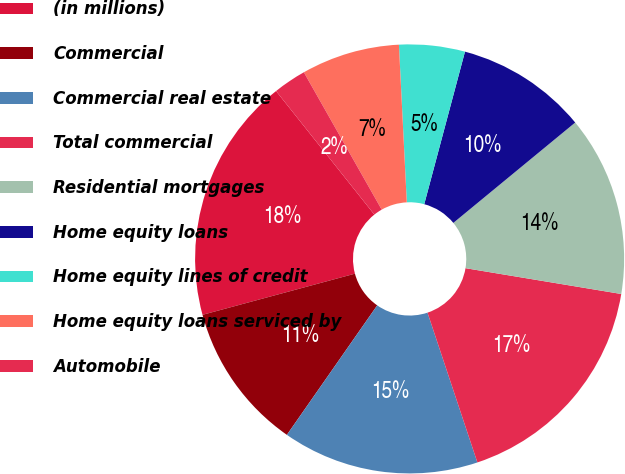Convert chart. <chart><loc_0><loc_0><loc_500><loc_500><pie_chart><fcel>(in millions)<fcel>Commercial<fcel>Commercial real estate<fcel>Total commercial<fcel>Residential mortgages<fcel>Home equity loans<fcel>Home equity lines of credit<fcel>Home equity loans serviced by<fcel>Automobile<nl><fcel>18.5%<fcel>11.11%<fcel>14.81%<fcel>17.27%<fcel>13.58%<fcel>9.88%<fcel>4.95%<fcel>7.41%<fcel>2.49%<nl></chart> 